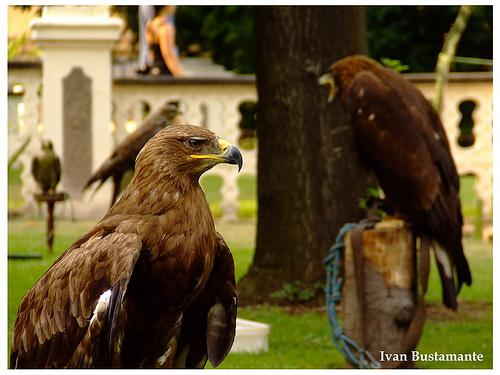Question: what type of bird is pictured?
Choices:
A. An eagle.
B. A blu jay.
C. A sparrow.
D. A hawk.
Answer with the letter. Answer: A Question: where are the birds perched?
Choices:
A. On a telephone wire.
B. In a garden.
C. On the roof.
D. On the laundry line.
Answer with the letter. Answer: B Question: how many birds are pictured?
Choices:
A. 1.
B. 2.
C. 3.
D. 4.
Answer with the letter. Answer: D Question: when is this picture taken?
Choices:
A. At Burning Man.
B. During the rainstorm.
C. During the day.
D. During the month of June.
Answer with the letter. Answer: C Question: what color are the birds' feathers?
Choices:
A. White.
B. Blue.
C. Brown.
D. Green.
Answer with the letter. Answer: C Question: who took this picture?
Choices:
A. Phil Spector.
B. Karl Marx.
C. Jane.
D. Ivan Bustamante.
Answer with the letter. Answer: D Question: why are the birds tied to their perch?
Choices:
A. So they cannot fly away.
B. So they cannot harm each other.
C. So they cannot eat all of their food at once.
D. So they cannot harm me.
Answer with the letter. Answer: A 